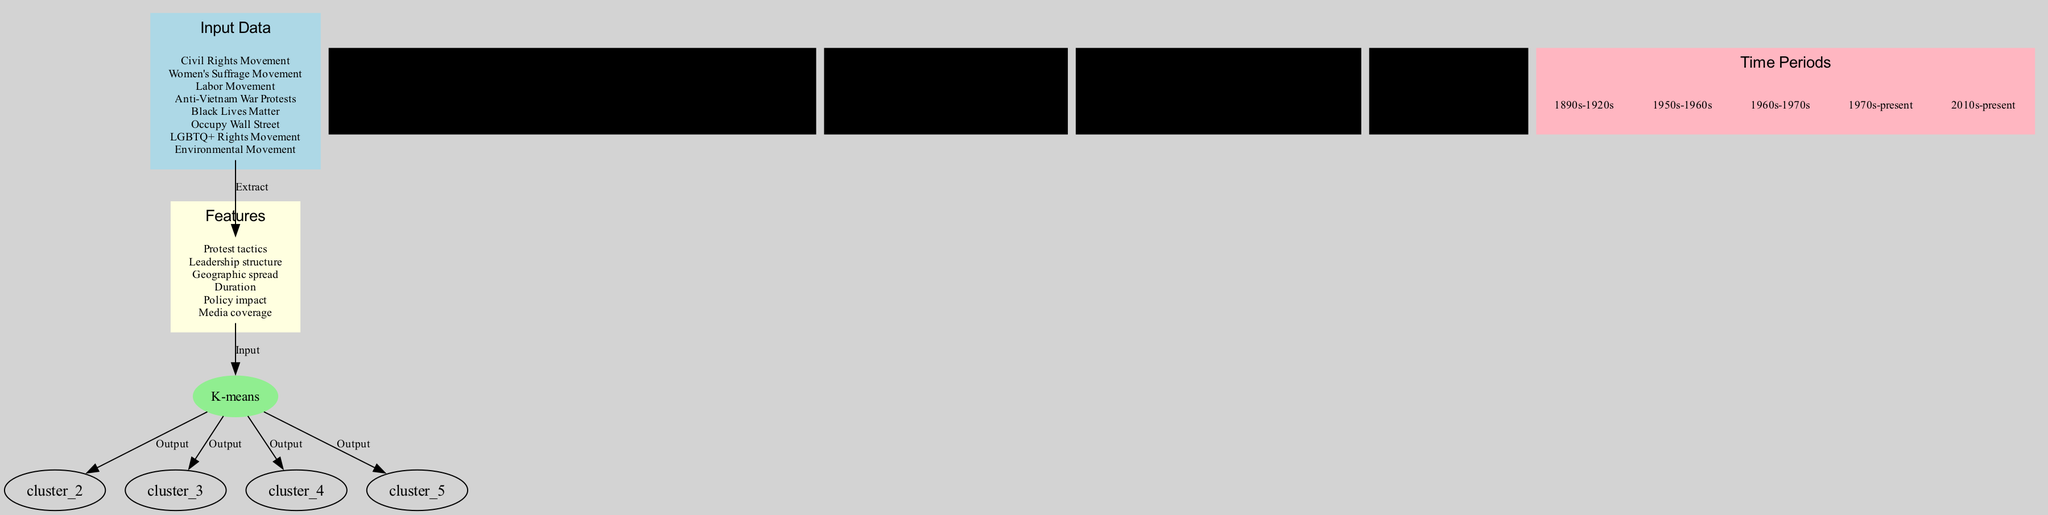What algorithm is used in this diagram? The diagram explicitly states that the clustering algorithm being used is K-means, which is identified in a distinct node within the flow.
Answer: K-means How many clusters are identified in the diagram? By examining the section of the diagram where clusters are represented, we can count a total of four distinct clusters named in their respective clusters.
Answer: 4 Which movement is part of the Anti-War and Social Justice Cluster? The membership of the Anti-War and Social Justice Cluster includes two specific movements: Anti-Vietnam War Protests and Black Lives Matter. Therefore, either of these can be an answer.
Answer: Anti-Vietnam War Protests What is the first step in the flow of this diagram? The first step in the flow is from the Input Data node to the Features node, which is indicated by an edge labeled "Extract".
Answer: Extract In which time period did the Women's Suffrage Movement predominantly occur? By looking at the era in which the Women's Suffrage Movement is located, it falls within the time period of 1890s-1920s, according to its historical context.
Answer: 1890s-1920s What feature is not represented in any of the clusters? The diagram does not explicitly assign any of the features to the Environmental Movement cluster; as it stands alone in the Single-Issue Cluster, it lacks shared features with the others.
Answer: None Which cluster contains the Labor Movement? The Labor Movement is found within the Economic Justice Cluster, which is clearly indicated and marked in the diagram.
Answer: Economic Justice Cluster What color represents the Input Data node? The Input Data node is colored light blue, which can be easily identified by examining the color attributes assigned to that section of the diagram.
Answer: Light blue 